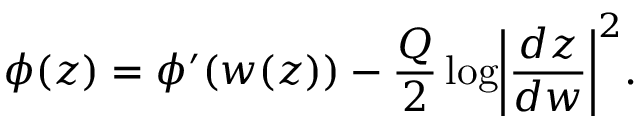Convert formula to latex. <formula><loc_0><loc_0><loc_500><loc_500>\phi ( z ) = \phi ^ { \prime } ( w ( z ) ) - \frac { Q } { 2 } \log \left | \frac { d z } { d w } \right | ^ { 2 } .</formula> 